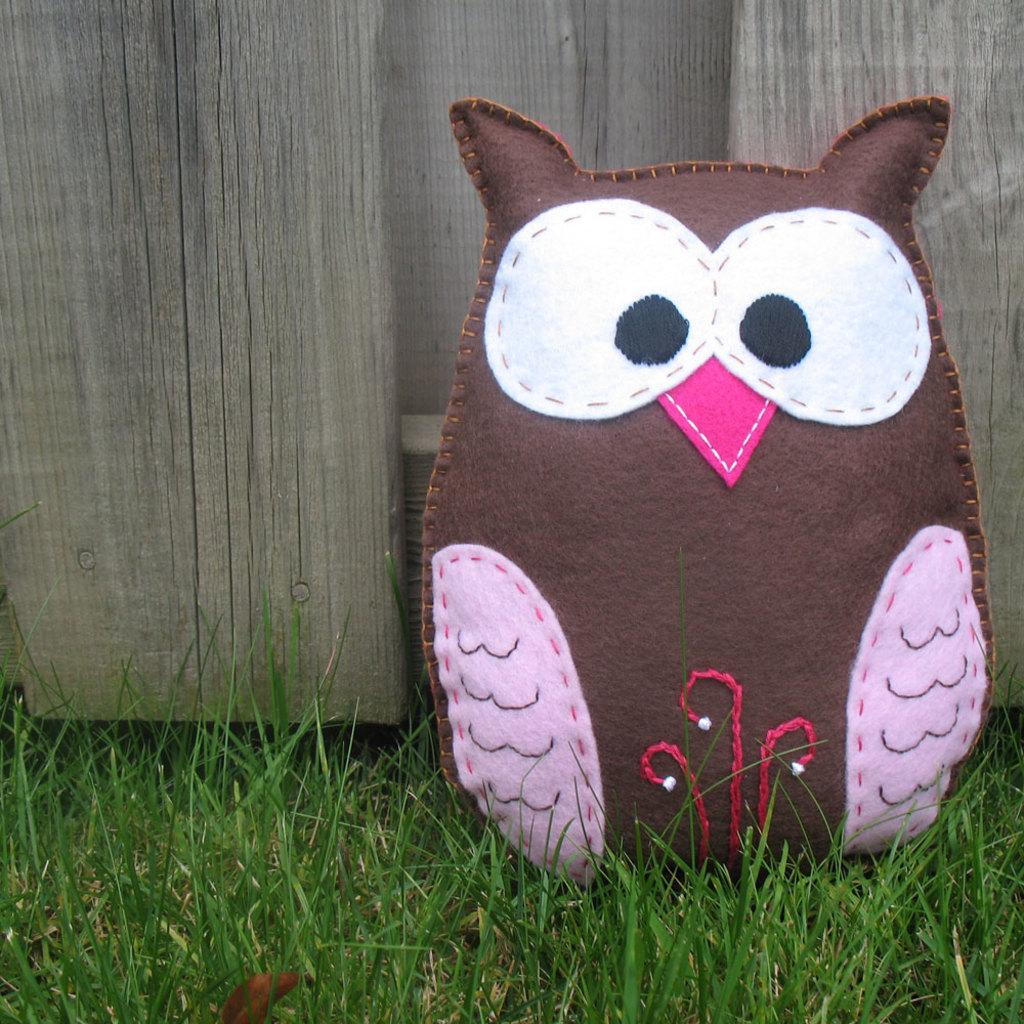What type of cushion is depicted in the image? There is a cushion in the image that resembles an owl. Where is the cushion located? The cushion is on the ground. What can be seen in the background of the image? There is grass and wood visible in the background of the image. What type of account is being discussed in the image? There is no account being discussed in the image; it features an owl-shaped cushion on the ground with a grass and wood background. 